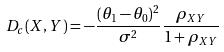Convert formula to latex. <formula><loc_0><loc_0><loc_500><loc_500>D _ { c } ( X , Y ) = - \frac { ( \theta _ { 1 } - \theta _ { 0 } ) ^ { 2 } } { \sigma ^ { 2 } } \frac { \rho _ { X Y } } { 1 + \rho _ { X Y } }</formula> 